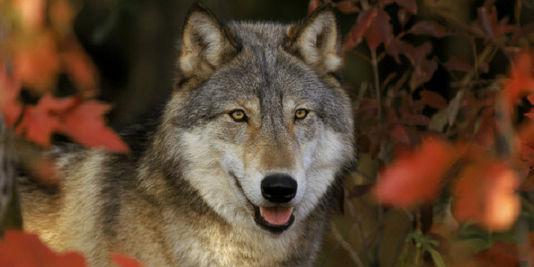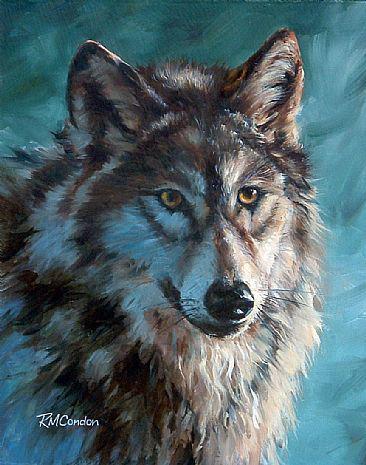The first image is the image on the left, the second image is the image on the right. Considering the images on both sides, is "The wolf in the image on the left is in front of red foliage." valid? Answer yes or no. Yes. The first image is the image on the left, the second image is the image on the right. For the images displayed, is the sentence "The wolf in the left image is looking left." factually correct? Answer yes or no. No. 